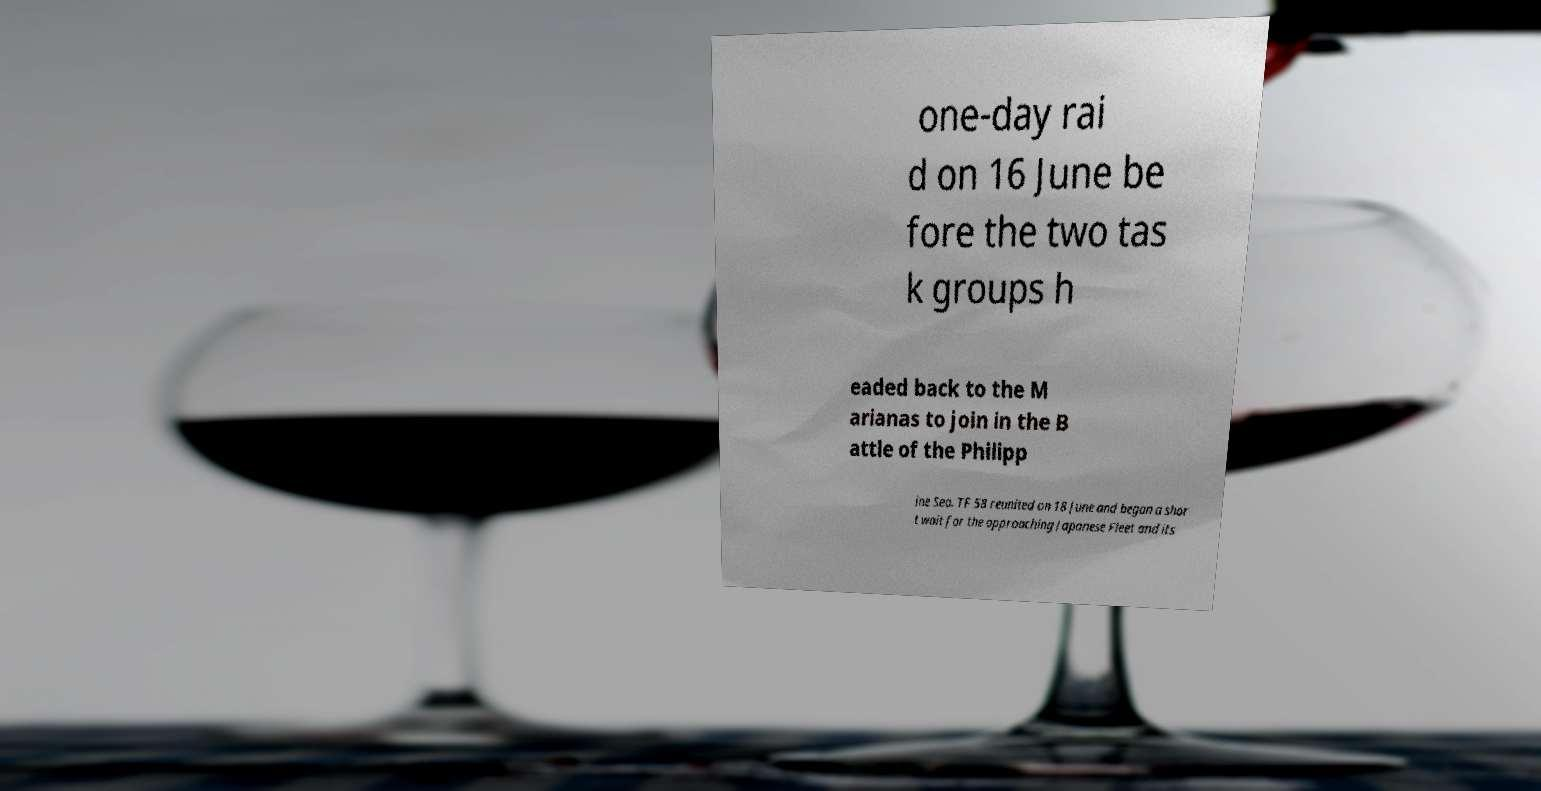Could you assist in decoding the text presented in this image and type it out clearly? one-day rai d on 16 June be fore the two tas k groups h eaded back to the M arianas to join in the B attle of the Philipp ine Sea. TF 58 reunited on 18 June and began a shor t wait for the approaching Japanese Fleet and its 